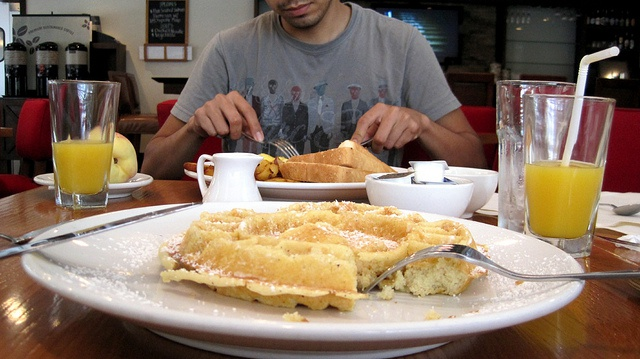Describe the objects in this image and their specific colors. I can see dining table in gray, lightgray, maroon, tan, and darkgray tones, people in gray, black, and maroon tones, cake in gray, khaki, and tan tones, cup in gray, orange, olive, and darkgray tones, and cup in gray, olive, maroon, and black tones in this image. 